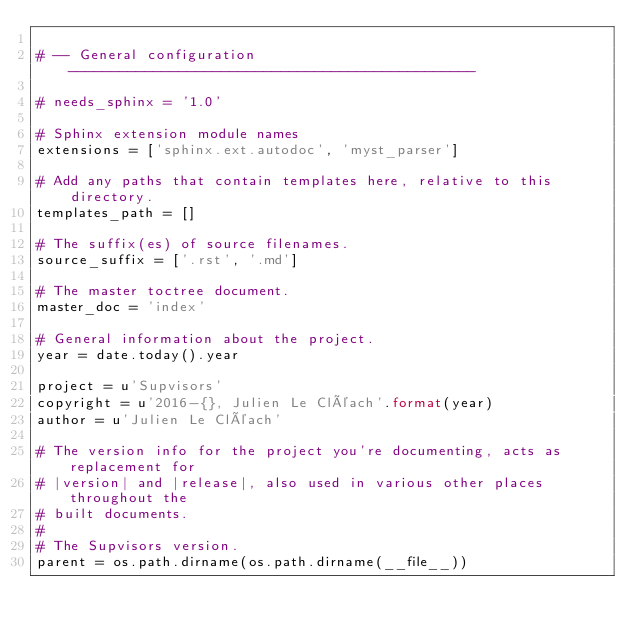<code> <loc_0><loc_0><loc_500><loc_500><_Python_>
# -- General configuration ------------------------------------------------

# needs_sphinx = '1.0'

# Sphinx extension module names
extensions = ['sphinx.ext.autodoc', 'myst_parser']

# Add any paths that contain templates here, relative to this directory.
templates_path = []

# The suffix(es) of source filenames.
source_suffix = ['.rst', '.md']

# The master toctree document.
master_doc = 'index'

# General information about the project.
year = date.today().year

project = u'Supvisors'
copyright = u'2016-{}, Julien Le Cléach'.format(year)
author = u'Julien Le Cléach'

# The version info for the project you're documenting, acts as replacement for
# |version| and |release|, also used in various other places throughout the
# built documents.
#
# The Supvisors version.
parent = os.path.dirname(os.path.dirname(__file__))</code> 